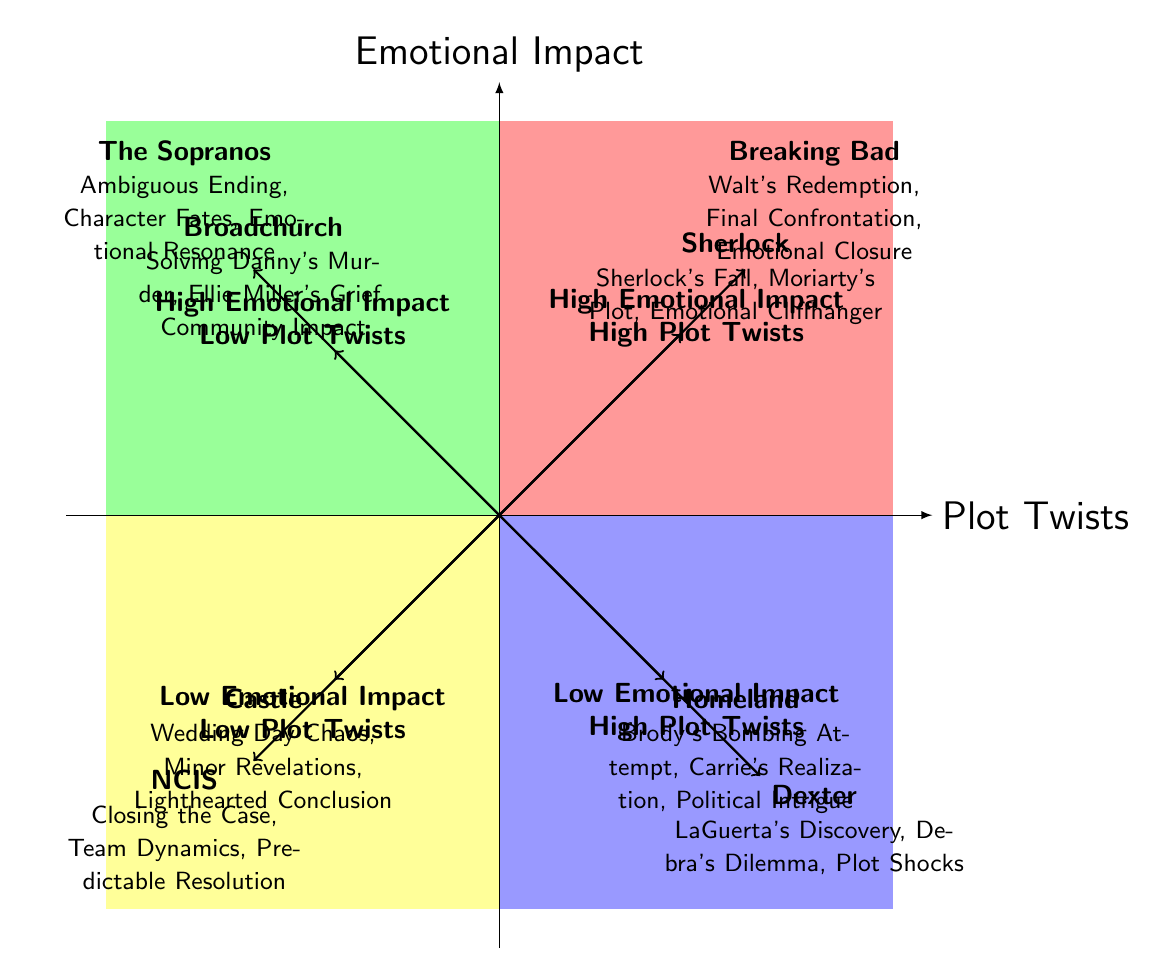What are the key elements of the season finale for "Breaking Bad"? According to the quadrants, "Breaking Bad" is located in Quadrant 1 (High Emotional Impact - High Plot Twists). The key elements listed for its season finale "Felina" include Walt's Redemption, Final Confrontation, and Emotional Closure.
Answer: Walt's Redemption, Final Confrontation, Emotional Closure How many shows are categorized under "Low Emotional Impact - High Plot Twists"? The quadrant for "Low Emotional Impact - High Plot Twists" contains two shows, "Dexter" and "Homeland". Therefore, to find the number of shows, simply count the entries in this quadrant.
Answer: 2 Which show features an ambiguous ending in its finale? The show that features an ambiguous ending in its finale is "The Sopranos" as indicated in Quadrant 2 (High Emotional Impact - Low Plot Twists).
Answer: The Sopranos Which quadrant contains "Castle"? "Castle" is located in Quadrant 4 (Low Emotional Impact - Low Plot Twists) as indicated by its position in the diagram and the characteristics assigned to this quadrant.
Answer: Quadrant 4 What is the emotional impact level of "Sherlock"? "Sherlock" is placed in Quadrant 1 (High Emotional Impact - High Plot Twists), which suggests that it has a high emotional impact as indicated by its position on the diagram.
Answer: High How does the emotional impact of "NCIS" compare to that of "Broadchurch"? "NCIS" is in Quadrant 4 (Low Emotional Impact - Low Plot Twists), while "Broadchurch" is in Quadrant 2 (High Emotional Impact - Low Plot Twists). This means "Broadchurch" has higher emotional impact than "NCIS".
Answer: Broadchurch has higher emotional impact What are the key plot twist elements for "Homeland"? For "Homeland," which is found in Quadrant 3 (Low Emotional Impact - High Plot Twists), the key elements noted include Brody's Bombing Attempt, Carrie’s Realization, and Political Intrigue.
Answer: Brody's Bombing Attempt, Carrie’s Realization, Political Intrigue In which quadrant would you find "The Sopranos" if its emotional impact decreased? If "The Sopranos" were to have a decreased emotional impact, it could potentially move to Quadrant 4 (Low Emotional Impact - Low Plot Twists), which suggests a lower level of both emotional impact and plot twists.
Answer: Quadrant 4 Which two shows share similar emotional impact but different plot twist levels? "The Sopranos" and "Broadchurch" both exhibit high emotional impact but differ in plot twist levels, as "The Sopranos" is in Quadrant 2 (High Emotional Impact - Low Plot Twists) and "Broadchurch" also lies in Quadrant 2 thus showing they share the same emotional impact level.
Answer: The Sopranos and Broadchurch 